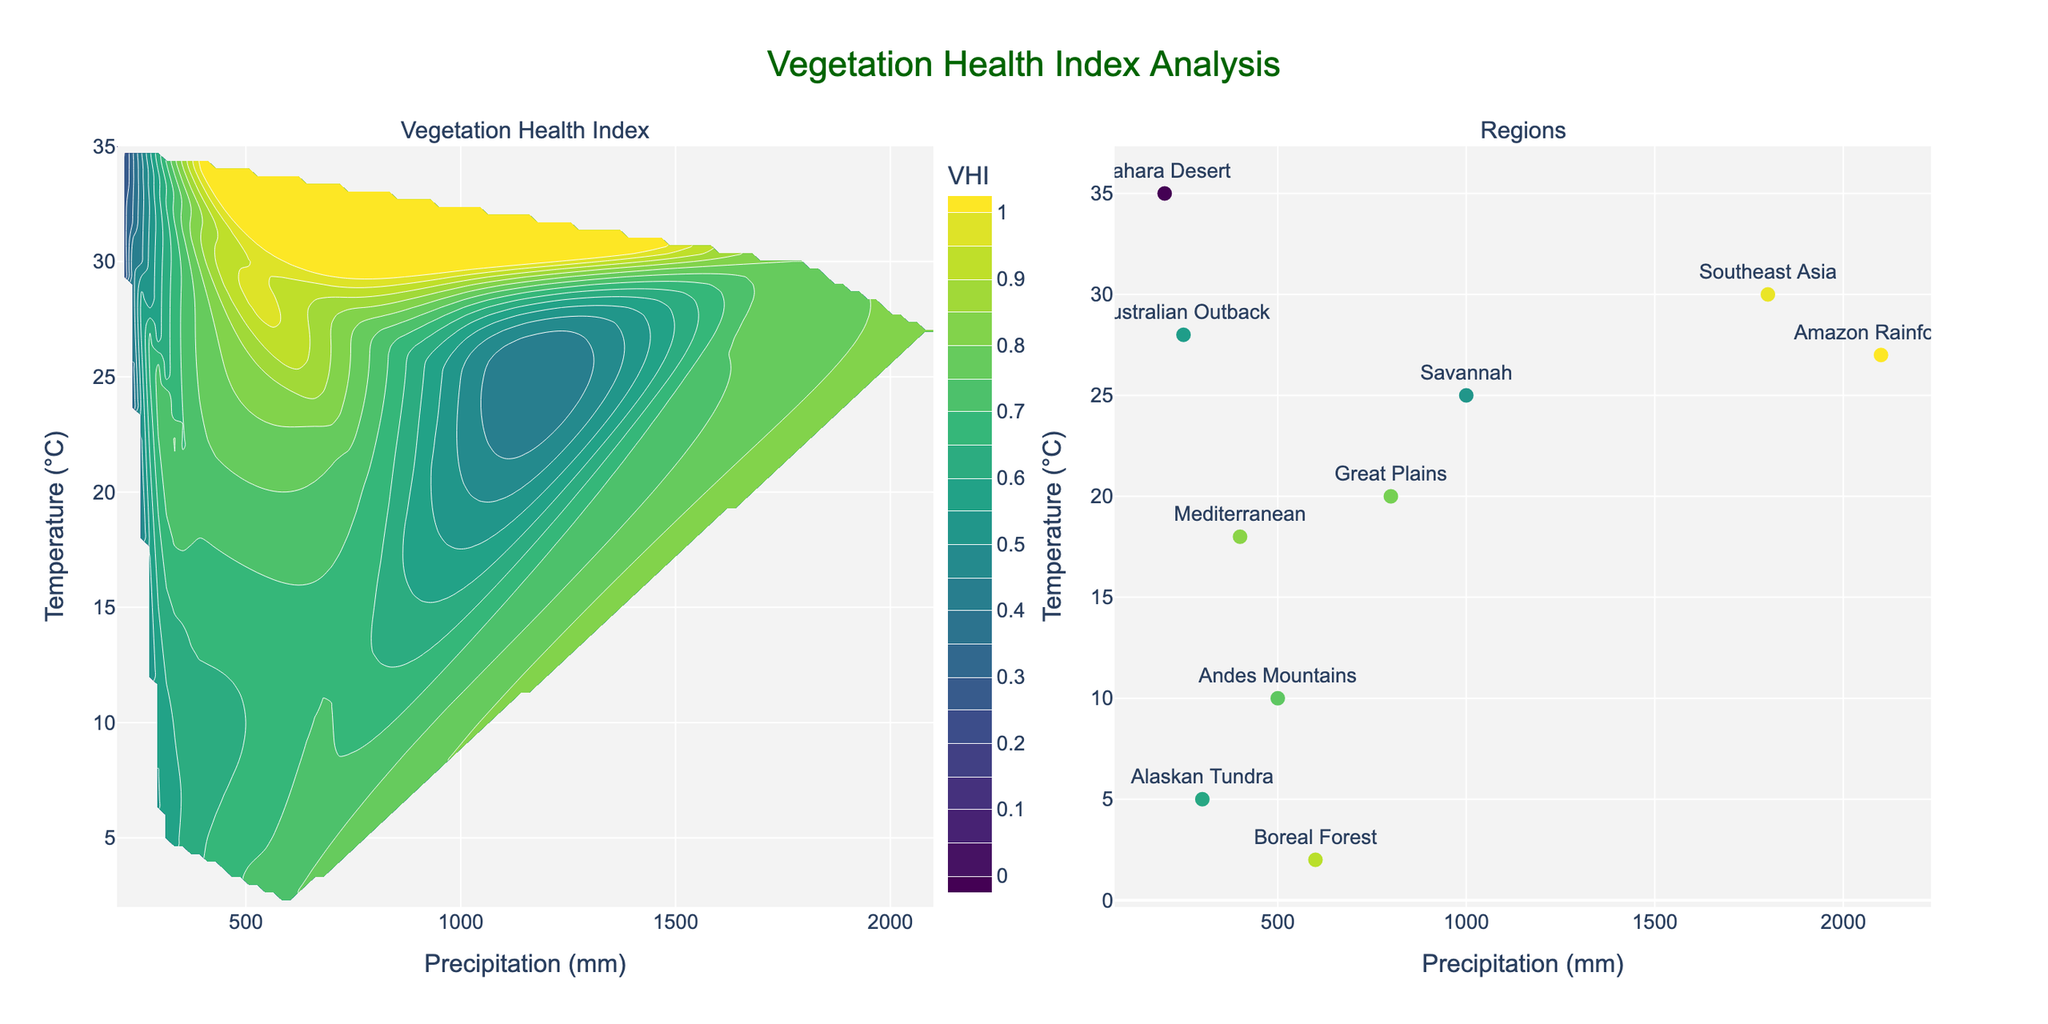What's the title of the figure? The title typically appears at the top center of a figure. In this case, it reads "Vegetation Health Index Analysis".
Answer: Vegetation Health Index Analysis What does the color scale represent in the contour plot? The color scale, located beside the contour plot, represents the Vegetation Health Index (VHI) values. Darker colors usually indicate lower VHI, while lighter colors represent higher VHI.
Answer: Vegetation Health Index Which region has the highest Vegetation Health Index in the scatter plot? Look for the region with the highest marker color intensity or refer to the hovertext showing VHI values, which in this case is the "Amazon Rainforest" with a VHI of 0.82.
Answer: Amazon Rainforest What are the x-axis and y-axis labels on the contour plot? The x-axis label on the contour plot is "Precipitation (mm)" and the y-axis label is "Temperature (°C)". These labels are located on the horizontal and vertical axes respectively.
Answer: Precipitation (mm) and Temperature (°C) How many data points are shown on the scatter plot? Count the number of markers (dots) on the scatter plot. There are 10 regions represented, so 10 data points are displayed.
Answer: 10 Which region has the lowest precipitation? In the scatter plot, locate the point with the smallest x-axis value (precipitation). The "Sahara Desert" has the lowest precipitation at 200 mm.
Answer: Sahara Desert Compare the Vegetation Health Index of the Boreal Forest and Savannah. Which one is higher? Find both regions on the scatter plot and compare their VHI values. The Boreal Forest has a VHI of 0.75, while Savannah has a VHI of 0.50. Therefore, Boreal Forest has a higher VHI.
Answer: Boreal Forest What is the range of VHI values shown on the contour plot? Examine the color bar on the contour plot to determine the range. The VHI ranges from 0 to 1.
Answer: 0 to 1 Identify the relationship between precipitation and VHI based on the contour plot. Examine the color gradients in the contour plot in relation to the precipitation axis. Generally, higher VHI values correspond with higher precipitation levels since areas with more precipitation tend to have greener, healthier vegetation.
Answer: Higher precipitation correlates with higher VHI Describe the VHI trend for regions with temperatures around 25°C. Look at the contour plot and identify the color bands near the 25°C mark on the y-axis. Compare the colors to the VHI values on the color bar. Regions with around 25°C tend to have variable VHI values, with both moderate and lower VHI seen.
Answer: VHI is variable, showing both moderate and lower values 